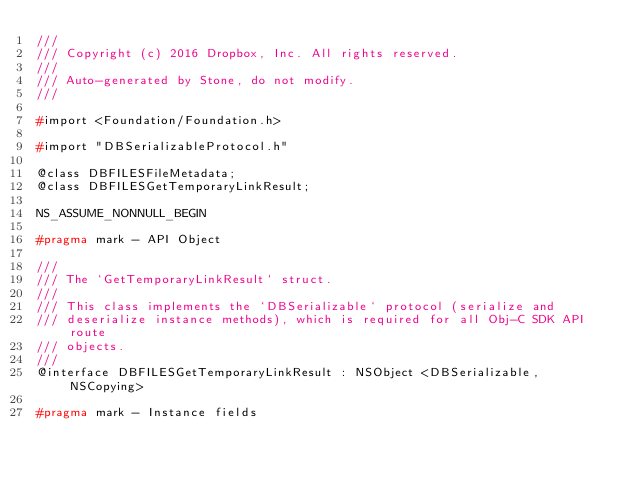Convert code to text. <code><loc_0><loc_0><loc_500><loc_500><_C_>///
/// Copyright (c) 2016 Dropbox, Inc. All rights reserved.
///
/// Auto-generated by Stone, do not modify.
///

#import <Foundation/Foundation.h>

#import "DBSerializableProtocol.h"

@class DBFILESFileMetadata;
@class DBFILESGetTemporaryLinkResult;

NS_ASSUME_NONNULL_BEGIN

#pragma mark - API Object

///
/// The `GetTemporaryLinkResult` struct.
///
/// This class implements the `DBSerializable` protocol (serialize and
/// deserialize instance methods), which is required for all Obj-C SDK API route
/// objects.
///
@interface DBFILESGetTemporaryLinkResult : NSObject <DBSerializable, NSCopying>

#pragma mark - Instance fields
</code> 